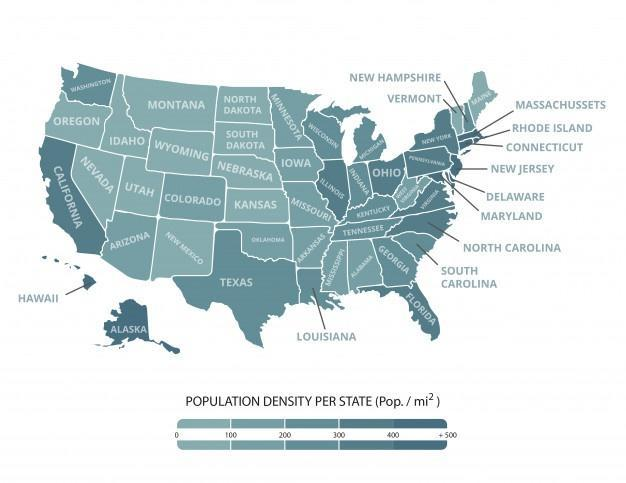How many groups of population density mentioned in this infographic?
Answer the question with a short phrase. 5 